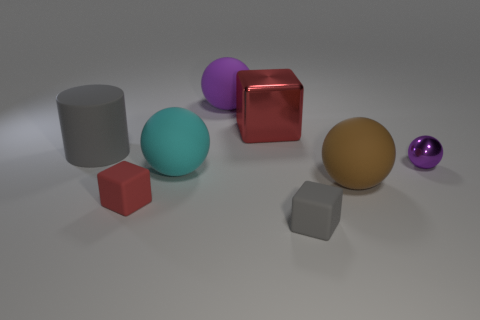Add 1 cyan rubber objects. How many objects exist? 9 Subtract all cylinders. How many objects are left? 7 Subtract 1 brown balls. How many objects are left? 7 Subtract all purple metallic cubes. Subtract all red things. How many objects are left? 6 Add 7 small red cubes. How many small red cubes are left? 8 Add 8 large purple balls. How many large purple balls exist? 9 